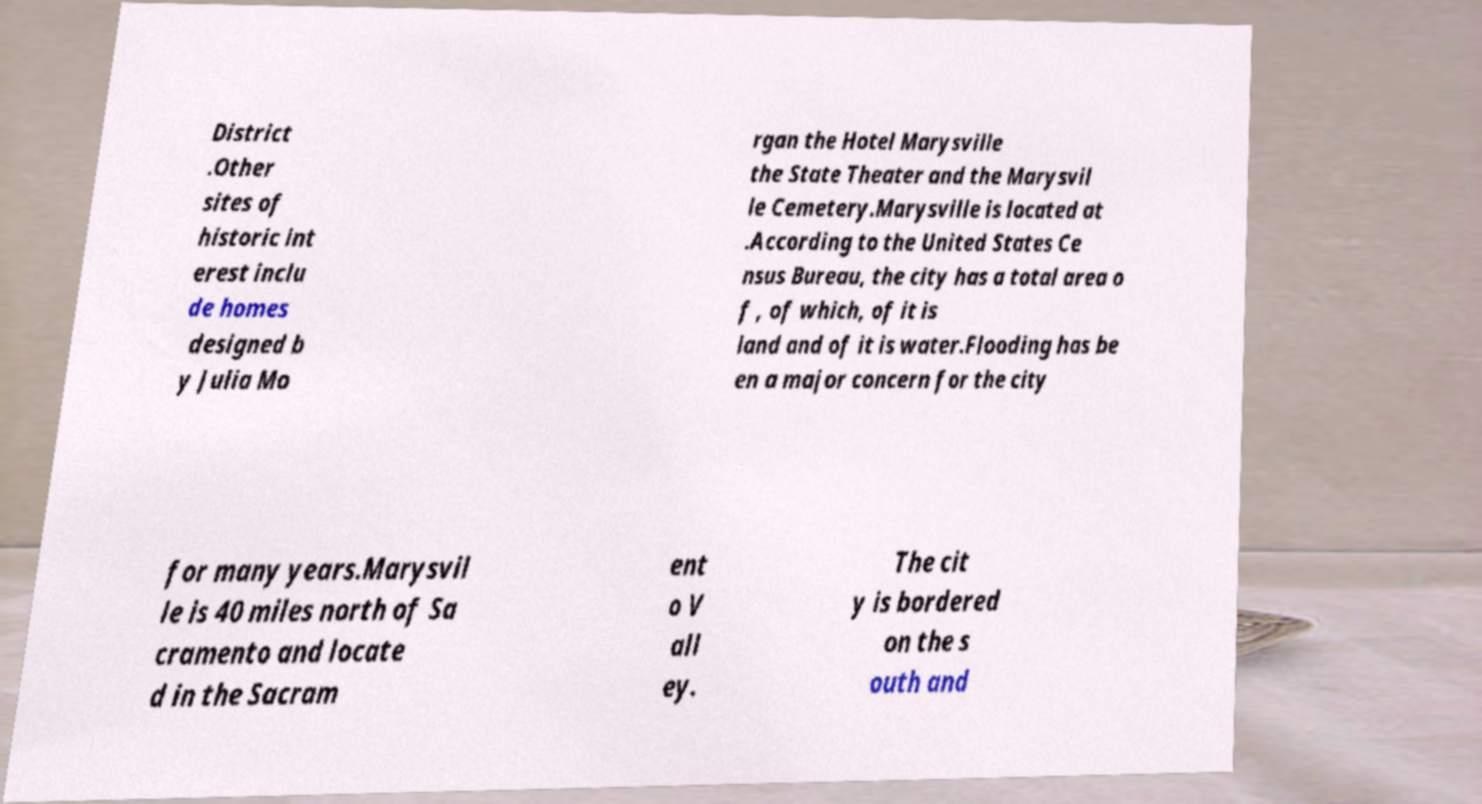Could you extract and type out the text from this image? District .Other sites of historic int erest inclu de homes designed b y Julia Mo rgan the Hotel Marysville the State Theater and the Marysvil le Cemetery.Marysville is located at .According to the United States Ce nsus Bureau, the city has a total area o f , of which, of it is land and of it is water.Flooding has be en a major concern for the city for many years.Marysvil le is 40 miles north of Sa cramento and locate d in the Sacram ent o V all ey. The cit y is bordered on the s outh and 